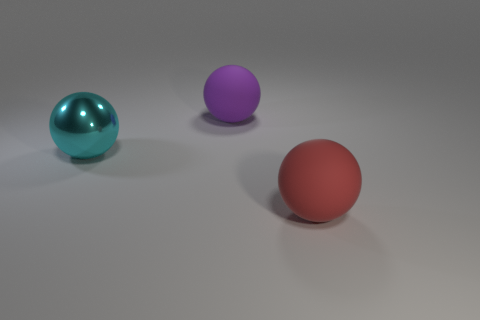Subtract all purple spheres. Subtract all gray cylinders. How many spheres are left? 2 Add 1 small yellow things. How many objects exist? 4 Add 1 purple matte things. How many purple matte things are left? 2 Add 1 big cyan metallic balls. How many big cyan metallic balls exist? 2 Subtract 0 gray cylinders. How many objects are left? 3 Subtract all big cyan spheres. Subtract all purple matte balls. How many objects are left? 1 